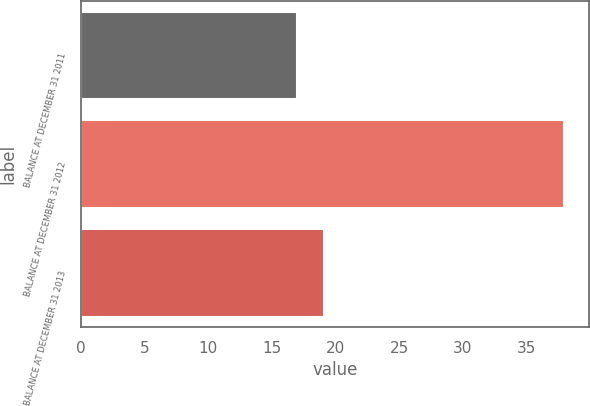Convert chart to OTSL. <chart><loc_0><loc_0><loc_500><loc_500><bar_chart><fcel>BALANCE AT DECEMBER 31 2011<fcel>BALANCE AT DECEMBER 31 2012<fcel>BALANCE AT DECEMBER 31 2013<nl><fcel>17<fcel>38<fcel>19.1<nl></chart> 